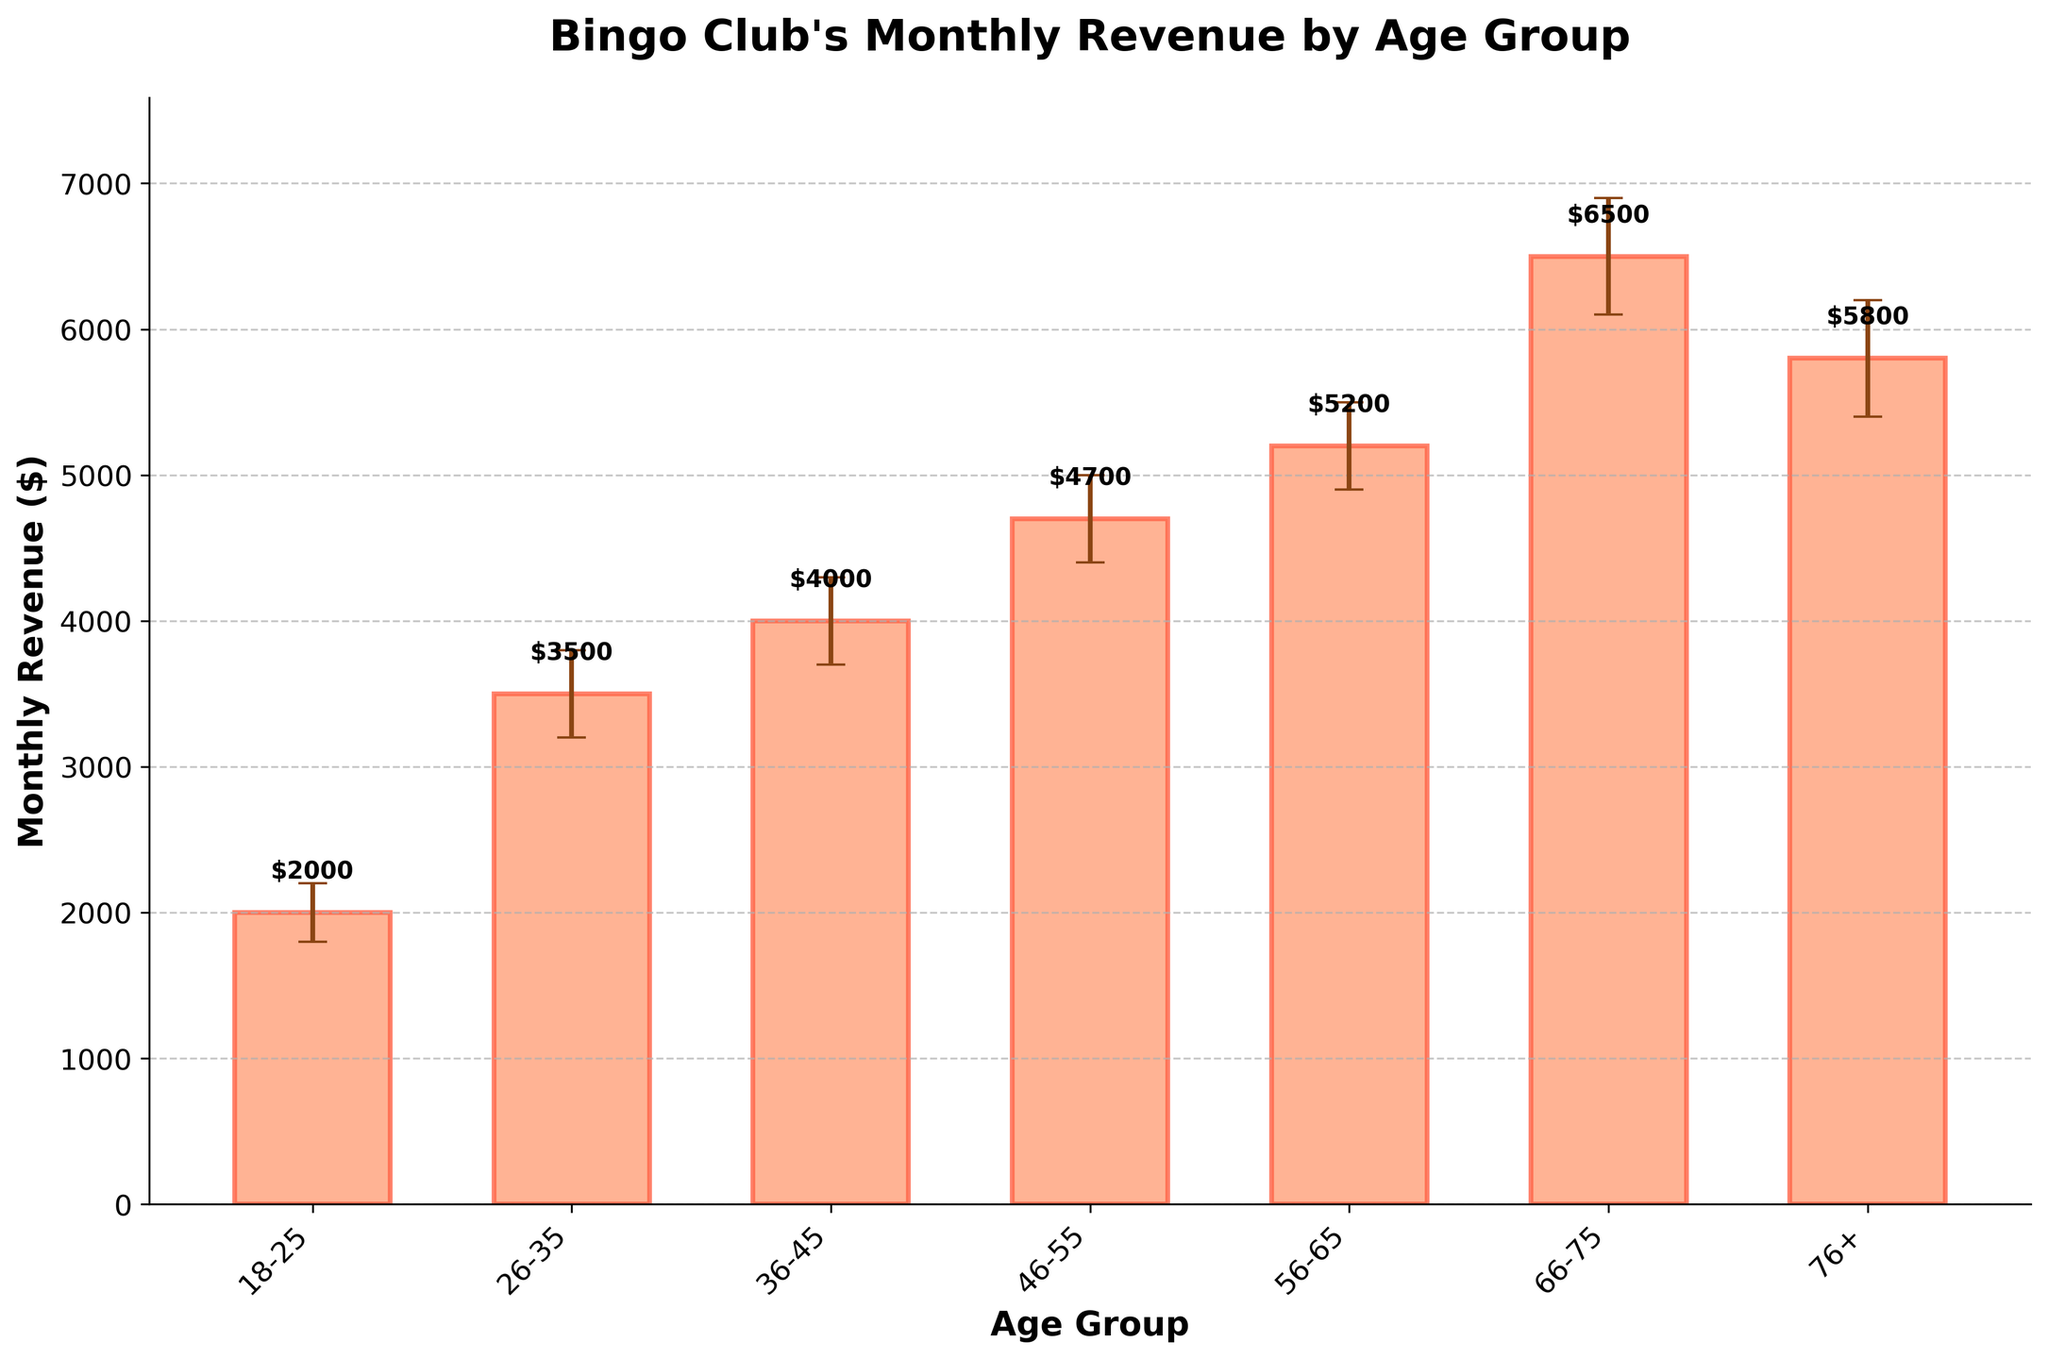What is the title of the plot? The title is found at the top of the plot.
Answer: Bingo Club's Monthly Revenue by Age Group Which age group has the highest monthly revenue? The highest bar reaches 6500 dollars, which corresponds to the age group 66-75.
Answer: 66-75 Which age group has the lowest confidence interval lower bound? The confidence interval lower bounds are shown by the error bars; the 18-25 age group's error bar starts at 1800, the lowest value.
Answer: 18-25 What is the approximate range of the revenue for the age group 76+? The error bars for the 76+ age group range from 5400 to 6200 dollars.
Answer: 5400 to 6200 How does the revenue for age group 36-45 compare to age group 56-65? The bar for 36-45 is at 4000, while the bar for 56-65 is at 5200, so the 56-65 age group has a higher revenue.
Answer: 4000 vs. 5200 What is the difference in monthly revenue between age groups 46-55 and 66-75? Subtract the value for 46-55, which is 4700, from the value for 66-75, which is 6500.
Answer: 1800 What is the average monthly revenue across all age groups? Sum all the monthly revenues (2000 + 3500 + 4000 + 4700 + 5200 + 6500 + 5800) and divide by the number of age groups, which is 7. The average is (31700 / 7).
Answer: 4528.57 Which two age groups have overlapping confidence intervals? The ranges for overlapping intervals are checked visually. The intervals for age groups 66-75 (6100-6900) and 76+ (5400-6200) overlap.
Answer: 66-75 and 76+ What is the monthly revenue for the age group 26-35? The height of the bar representing the 26-35 age group indicates its monthly revenue, which is 3500 dollars.
Answer: 3500 